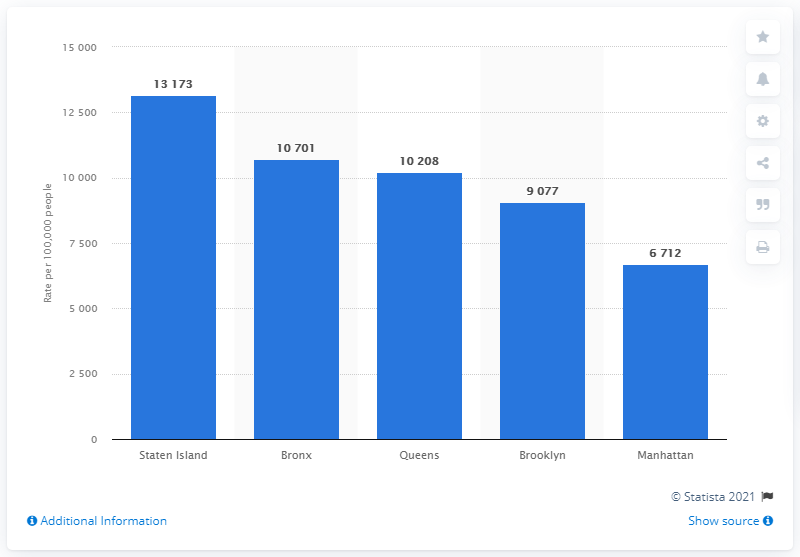Identify some key points in this picture. The borough of Manhattan has the lowest rate of coronavirus cases. According to the latest data, Manhattan has the lowest rate of coronavirus cases among all the boroughs in New York City. 